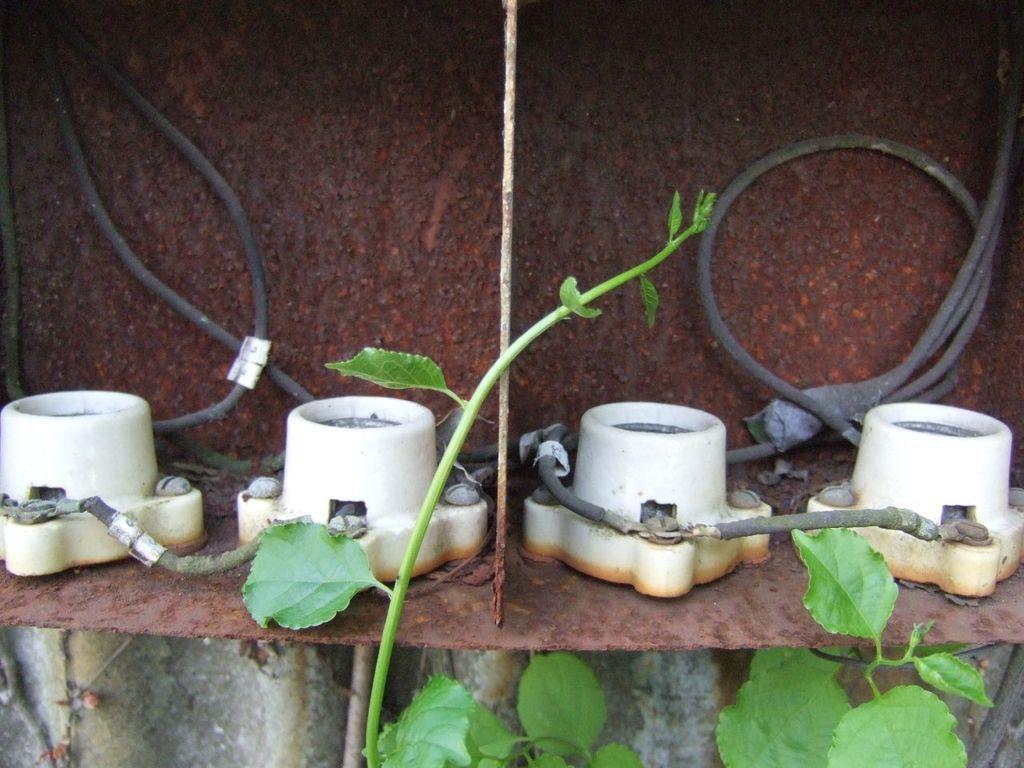In one or two sentences, can you explain what this image depicts? In this image in the center there is one box, and in the box there are some objects and wires. At the bottom of the image there are some leaves, and in the background there is some object. 